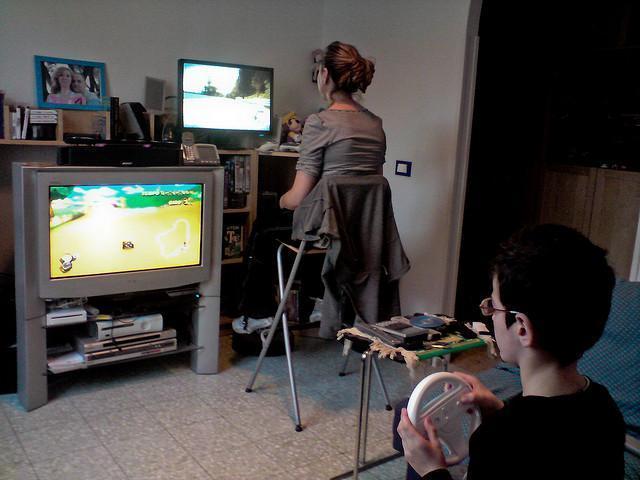How many people are in the room?
Give a very brief answer. 2. How many people in this shot?
Give a very brief answer. 2. How many chairs are visible?
Give a very brief answer. 1. How many tvs are visible?
Give a very brief answer. 2. How many people are there?
Give a very brief answer. 2. How many cars have headlights on?
Give a very brief answer. 0. 